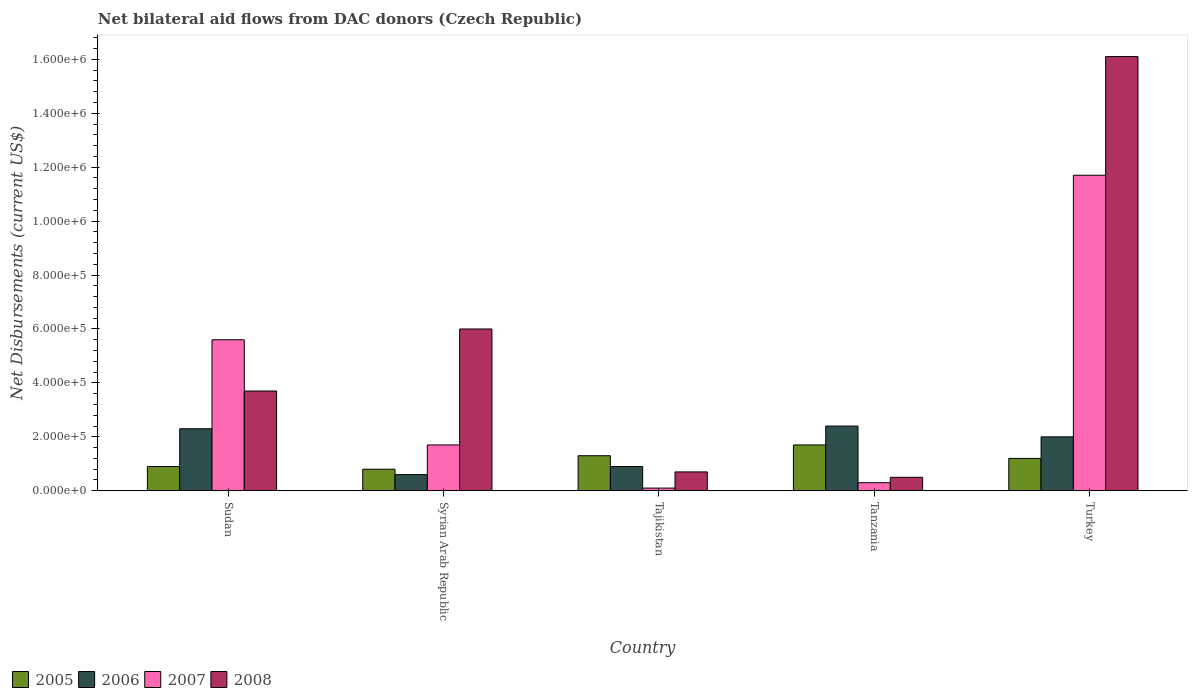Are the number of bars on each tick of the X-axis equal?
Your response must be concise. Yes. What is the label of the 2nd group of bars from the left?
Your answer should be compact. Syrian Arab Republic. In how many cases, is the number of bars for a given country not equal to the number of legend labels?
Your response must be concise. 0. Across all countries, what is the maximum net bilateral aid flows in 2005?
Make the answer very short. 1.70e+05. In which country was the net bilateral aid flows in 2005 maximum?
Provide a succinct answer. Tanzania. In which country was the net bilateral aid flows in 2007 minimum?
Offer a very short reply. Tajikistan. What is the total net bilateral aid flows in 2005 in the graph?
Your answer should be very brief. 5.90e+05. What is the difference between the net bilateral aid flows in 2007 in Tajikistan and the net bilateral aid flows in 2006 in Sudan?
Give a very brief answer. -2.20e+05. What is the average net bilateral aid flows in 2005 per country?
Provide a short and direct response. 1.18e+05. What is the difference between the highest and the lowest net bilateral aid flows in 2008?
Ensure brevity in your answer.  1.56e+06. Is the sum of the net bilateral aid flows in 2007 in Tanzania and Turkey greater than the maximum net bilateral aid flows in 2006 across all countries?
Your response must be concise. Yes. Is it the case that in every country, the sum of the net bilateral aid flows in 2006 and net bilateral aid flows in 2005 is greater than the sum of net bilateral aid flows in 2008 and net bilateral aid flows in 2007?
Provide a short and direct response. No. What does the 3rd bar from the left in Turkey represents?
Keep it short and to the point. 2007. Is it the case that in every country, the sum of the net bilateral aid flows in 2006 and net bilateral aid flows in 2005 is greater than the net bilateral aid flows in 2007?
Provide a short and direct response. No. How many bars are there?
Offer a terse response. 20. Are all the bars in the graph horizontal?
Your answer should be very brief. No. How many countries are there in the graph?
Your response must be concise. 5. Are the values on the major ticks of Y-axis written in scientific E-notation?
Your response must be concise. Yes. Does the graph contain grids?
Keep it short and to the point. No. Where does the legend appear in the graph?
Provide a succinct answer. Bottom left. How are the legend labels stacked?
Provide a short and direct response. Horizontal. What is the title of the graph?
Make the answer very short. Net bilateral aid flows from DAC donors (Czech Republic). Does "2013" appear as one of the legend labels in the graph?
Your answer should be very brief. No. What is the label or title of the Y-axis?
Your response must be concise. Net Disbursements (current US$). What is the Net Disbursements (current US$) in 2006 in Sudan?
Provide a short and direct response. 2.30e+05. What is the Net Disbursements (current US$) of 2007 in Sudan?
Offer a terse response. 5.60e+05. What is the Net Disbursements (current US$) of 2005 in Syrian Arab Republic?
Your response must be concise. 8.00e+04. What is the Net Disbursements (current US$) in 2006 in Syrian Arab Republic?
Provide a succinct answer. 6.00e+04. What is the Net Disbursements (current US$) of 2008 in Syrian Arab Republic?
Provide a succinct answer. 6.00e+05. What is the Net Disbursements (current US$) in 2005 in Tanzania?
Provide a short and direct response. 1.70e+05. What is the Net Disbursements (current US$) of 2006 in Tanzania?
Offer a very short reply. 2.40e+05. What is the Net Disbursements (current US$) in 2007 in Tanzania?
Provide a short and direct response. 3.00e+04. What is the Net Disbursements (current US$) in 2006 in Turkey?
Ensure brevity in your answer.  2.00e+05. What is the Net Disbursements (current US$) of 2007 in Turkey?
Offer a very short reply. 1.17e+06. What is the Net Disbursements (current US$) of 2008 in Turkey?
Your answer should be compact. 1.61e+06. Across all countries, what is the maximum Net Disbursements (current US$) in 2005?
Provide a succinct answer. 1.70e+05. Across all countries, what is the maximum Net Disbursements (current US$) in 2007?
Keep it short and to the point. 1.17e+06. Across all countries, what is the maximum Net Disbursements (current US$) in 2008?
Keep it short and to the point. 1.61e+06. Across all countries, what is the minimum Net Disbursements (current US$) of 2005?
Offer a terse response. 8.00e+04. Across all countries, what is the minimum Net Disbursements (current US$) in 2006?
Offer a very short reply. 6.00e+04. Across all countries, what is the minimum Net Disbursements (current US$) of 2007?
Provide a succinct answer. 10000. Across all countries, what is the minimum Net Disbursements (current US$) in 2008?
Provide a short and direct response. 5.00e+04. What is the total Net Disbursements (current US$) of 2005 in the graph?
Keep it short and to the point. 5.90e+05. What is the total Net Disbursements (current US$) of 2006 in the graph?
Provide a succinct answer. 8.20e+05. What is the total Net Disbursements (current US$) in 2007 in the graph?
Offer a very short reply. 1.94e+06. What is the total Net Disbursements (current US$) in 2008 in the graph?
Your answer should be very brief. 2.70e+06. What is the difference between the Net Disbursements (current US$) of 2006 in Sudan and that in Syrian Arab Republic?
Your answer should be very brief. 1.70e+05. What is the difference between the Net Disbursements (current US$) in 2006 in Sudan and that in Tajikistan?
Your response must be concise. 1.40e+05. What is the difference between the Net Disbursements (current US$) in 2007 in Sudan and that in Tajikistan?
Ensure brevity in your answer.  5.50e+05. What is the difference between the Net Disbursements (current US$) of 2008 in Sudan and that in Tajikistan?
Ensure brevity in your answer.  3.00e+05. What is the difference between the Net Disbursements (current US$) of 2005 in Sudan and that in Tanzania?
Your answer should be very brief. -8.00e+04. What is the difference between the Net Disbursements (current US$) of 2006 in Sudan and that in Tanzania?
Your answer should be compact. -10000. What is the difference between the Net Disbursements (current US$) in 2007 in Sudan and that in Tanzania?
Keep it short and to the point. 5.30e+05. What is the difference between the Net Disbursements (current US$) in 2008 in Sudan and that in Tanzania?
Offer a terse response. 3.20e+05. What is the difference between the Net Disbursements (current US$) in 2005 in Sudan and that in Turkey?
Offer a very short reply. -3.00e+04. What is the difference between the Net Disbursements (current US$) in 2006 in Sudan and that in Turkey?
Ensure brevity in your answer.  3.00e+04. What is the difference between the Net Disbursements (current US$) in 2007 in Sudan and that in Turkey?
Make the answer very short. -6.10e+05. What is the difference between the Net Disbursements (current US$) in 2008 in Sudan and that in Turkey?
Provide a short and direct response. -1.24e+06. What is the difference between the Net Disbursements (current US$) in 2005 in Syrian Arab Republic and that in Tajikistan?
Provide a succinct answer. -5.00e+04. What is the difference between the Net Disbursements (current US$) in 2006 in Syrian Arab Republic and that in Tajikistan?
Give a very brief answer. -3.00e+04. What is the difference between the Net Disbursements (current US$) of 2007 in Syrian Arab Republic and that in Tajikistan?
Make the answer very short. 1.60e+05. What is the difference between the Net Disbursements (current US$) of 2008 in Syrian Arab Republic and that in Tajikistan?
Keep it short and to the point. 5.30e+05. What is the difference between the Net Disbursements (current US$) of 2006 in Syrian Arab Republic and that in Tanzania?
Your answer should be very brief. -1.80e+05. What is the difference between the Net Disbursements (current US$) of 2007 in Syrian Arab Republic and that in Tanzania?
Your answer should be compact. 1.40e+05. What is the difference between the Net Disbursements (current US$) in 2005 in Syrian Arab Republic and that in Turkey?
Provide a short and direct response. -4.00e+04. What is the difference between the Net Disbursements (current US$) of 2006 in Syrian Arab Republic and that in Turkey?
Your answer should be very brief. -1.40e+05. What is the difference between the Net Disbursements (current US$) in 2007 in Syrian Arab Republic and that in Turkey?
Your answer should be compact. -1.00e+06. What is the difference between the Net Disbursements (current US$) in 2008 in Syrian Arab Republic and that in Turkey?
Provide a succinct answer. -1.01e+06. What is the difference between the Net Disbursements (current US$) of 2005 in Tajikistan and that in Tanzania?
Offer a very short reply. -4.00e+04. What is the difference between the Net Disbursements (current US$) of 2006 in Tajikistan and that in Tanzania?
Give a very brief answer. -1.50e+05. What is the difference between the Net Disbursements (current US$) in 2008 in Tajikistan and that in Tanzania?
Give a very brief answer. 2.00e+04. What is the difference between the Net Disbursements (current US$) in 2007 in Tajikistan and that in Turkey?
Your response must be concise. -1.16e+06. What is the difference between the Net Disbursements (current US$) in 2008 in Tajikistan and that in Turkey?
Provide a short and direct response. -1.54e+06. What is the difference between the Net Disbursements (current US$) in 2007 in Tanzania and that in Turkey?
Keep it short and to the point. -1.14e+06. What is the difference between the Net Disbursements (current US$) of 2008 in Tanzania and that in Turkey?
Your answer should be very brief. -1.56e+06. What is the difference between the Net Disbursements (current US$) of 2005 in Sudan and the Net Disbursements (current US$) of 2006 in Syrian Arab Republic?
Your response must be concise. 3.00e+04. What is the difference between the Net Disbursements (current US$) in 2005 in Sudan and the Net Disbursements (current US$) in 2008 in Syrian Arab Republic?
Offer a very short reply. -5.10e+05. What is the difference between the Net Disbursements (current US$) in 2006 in Sudan and the Net Disbursements (current US$) in 2008 in Syrian Arab Republic?
Your answer should be very brief. -3.70e+05. What is the difference between the Net Disbursements (current US$) of 2005 in Sudan and the Net Disbursements (current US$) of 2007 in Tajikistan?
Make the answer very short. 8.00e+04. What is the difference between the Net Disbursements (current US$) of 2006 in Sudan and the Net Disbursements (current US$) of 2007 in Tajikistan?
Provide a short and direct response. 2.20e+05. What is the difference between the Net Disbursements (current US$) in 2006 in Sudan and the Net Disbursements (current US$) in 2008 in Tajikistan?
Your answer should be compact. 1.60e+05. What is the difference between the Net Disbursements (current US$) in 2007 in Sudan and the Net Disbursements (current US$) in 2008 in Tajikistan?
Give a very brief answer. 4.90e+05. What is the difference between the Net Disbursements (current US$) in 2005 in Sudan and the Net Disbursements (current US$) in 2007 in Tanzania?
Your answer should be compact. 6.00e+04. What is the difference between the Net Disbursements (current US$) of 2005 in Sudan and the Net Disbursements (current US$) of 2008 in Tanzania?
Offer a very short reply. 4.00e+04. What is the difference between the Net Disbursements (current US$) in 2007 in Sudan and the Net Disbursements (current US$) in 2008 in Tanzania?
Your response must be concise. 5.10e+05. What is the difference between the Net Disbursements (current US$) in 2005 in Sudan and the Net Disbursements (current US$) in 2006 in Turkey?
Your answer should be very brief. -1.10e+05. What is the difference between the Net Disbursements (current US$) of 2005 in Sudan and the Net Disbursements (current US$) of 2007 in Turkey?
Your answer should be very brief. -1.08e+06. What is the difference between the Net Disbursements (current US$) of 2005 in Sudan and the Net Disbursements (current US$) of 2008 in Turkey?
Offer a terse response. -1.52e+06. What is the difference between the Net Disbursements (current US$) in 2006 in Sudan and the Net Disbursements (current US$) in 2007 in Turkey?
Your answer should be compact. -9.40e+05. What is the difference between the Net Disbursements (current US$) in 2006 in Sudan and the Net Disbursements (current US$) in 2008 in Turkey?
Your answer should be very brief. -1.38e+06. What is the difference between the Net Disbursements (current US$) of 2007 in Sudan and the Net Disbursements (current US$) of 2008 in Turkey?
Give a very brief answer. -1.05e+06. What is the difference between the Net Disbursements (current US$) of 2005 in Syrian Arab Republic and the Net Disbursements (current US$) of 2006 in Tajikistan?
Give a very brief answer. -10000. What is the difference between the Net Disbursements (current US$) in 2005 in Syrian Arab Republic and the Net Disbursements (current US$) in 2007 in Tajikistan?
Provide a succinct answer. 7.00e+04. What is the difference between the Net Disbursements (current US$) of 2006 in Syrian Arab Republic and the Net Disbursements (current US$) of 2007 in Tajikistan?
Your answer should be compact. 5.00e+04. What is the difference between the Net Disbursements (current US$) of 2005 in Syrian Arab Republic and the Net Disbursements (current US$) of 2008 in Tanzania?
Keep it short and to the point. 3.00e+04. What is the difference between the Net Disbursements (current US$) of 2007 in Syrian Arab Republic and the Net Disbursements (current US$) of 2008 in Tanzania?
Give a very brief answer. 1.20e+05. What is the difference between the Net Disbursements (current US$) in 2005 in Syrian Arab Republic and the Net Disbursements (current US$) in 2007 in Turkey?
Your answer should be very brief. -1.09e+06. What is the difference between the Net Disbursements (current US$) of 2005 in Syrian Arab Republic and the Net Disbursements (current US$) of 2008 in Turkey?
Keep it short and to the point. -1.53e+06. What is the difference between the Net Disbursements (current US$) in 2006 in Syrian Arab Republic and the Net Disbursements (current US$) in 2007 in Turkey?
Keep it short and to the point. -1.11e+06. What is the difference between the Net Disbursements (current US$) in 2006 in Syrian Arab Republic and the Net Disbursements (current US$) in 2008 in Turkey?
Make the answer very short. -1.55e+06. What is the difference between the Net Disbursements (current US$) of 2007 in Syrian Arab Republic and the Net Disbursements (current US$) of 2008 in Turkey?
Your answer should be very brief. -1.44e+06. What is the difference between the Net Disbursements (current US$) in 2005 in Tajikistan and the Net Disbursements (current US$) in 2006 in Tanzania?
Your answer should be very brief. -1.10e+05. What is the difference between the Net Disbursements (current US$) in 2005 in Tajikistan and the Net Disbursements (current US$) in 2008 in Tanzania?
Your response must be concise. 8.00e+04. What is the difference between the Net Disbursements (current US$) in 2007 in Tajikistan and the Net Disbursements (current US$) in 2008 in Tanzania?
Ensure brevity in your answer.  -4.00e+04. What is the difference between the Net Disbursements (current US$) in 2005 in Tajikistan and the Net Disbursements (current US$) in 2007 in Turkey?
Provide a succinct answer. -1.04e+06. What is the difference between the Net Disbursements (current US$) of 2005 in Tajikistan and the Net Disbursements (current US$) of 2008 in Turkey?
Offer a terse response. -1.48e+06. What is the difference between the Net Disbursements (current US$) in 2006 in Tajikistan and the Net Disbursements (current US$) in 2007 in Turkey?
Your answer should be compact. -1.08e+06. What is the difference between the Net Disbursements (current US$) of 2006 in Tajikistan and the Net Disbursements (current US$) of 2008 in Turkey?
Ensure brevity in your answer.  -1.52e+06. What is the difference between the Net Disbursements (current US$) in 2007 in Tajikistan and the Net Disbursements (current US$) in 2008 in Turkey?
Your answer should be compact. -1.60e+06. What is the difference between the Net Disbursements (current US$) in 2005 in Tanzania and the Net Disbursements (current US$) in 2006 in Turkey?
Make the answer very short. -3.00e+04. What is the difference between the Net Disbursements (current US$) of 2005 in Tanzania and the Net Disbursements (current US$) of 2007 in Turkey?
Make the answer very short. -1.00e+06. What is the difference between the Net Disbursements (current US$) in 2005 in Tanzania and the Net Disbursements (current US$) in 2008 in Turkey?
Make the answer very short. -1.44e+06. What is the difference between the Net Disbursements (current US$) of 2006 in Tanzania and the Net Disbursements (current US$) of 2007 in Turkey?
Provide a short and direct response. -9.30e+05. What is the difference between the Net Disbursements (current US$) in 2006 in Tanzania and the Net Disbursements (current US$) in 2008 in Turkey?
Ensure brevity in your answer.  -1.37e+06. What is the difference between the Net Disbursements (current US$) of 2007 in Tanzania and the Net Disbursements (current US$) of 2008 in Turkey?
Ensure brevity in your answer.  -1.58e+06. What is the average Net Disbursements (current US$) of 2005 per country?
Give a very brief answer. 1.18e+05. What is the average Net Disbursements (current US$) in 2006 per country?
Provide a short and direct response. 1.64e+05. What is the average Net Disbursements (current US$) in 2007 per country?
Provide a succinct answer. 3.88e+05. What is the average Net Disbursements (current US$) in 2008 per country?
Ensure brevity in your answer.  5.40e+05. What is the difference between the Net Disbursements (current US$) of 2005 and Net Disbursements (current US$) of 2006 in Sudan?
Your answer should be very brief. -1.40e+05. What is the difference between the Net Disbursements (current US$) of 2005 and Net Disbursements (current US$) of 2007 in Sudan?
Your answer should be compact. -4.70e+05. What is the difference between the Net Disbursements (current US$) in 2005 and Net Disbursements (current US$) in 2008 in Sudan?
Your response must be concise. -2.80e+05. What is the difference between the Net Disbursements (current US$) of 2006 and Net Disbursements (current US$) of 2007 in Sudan?
Offer a very short reply. -3.30e+05. What is the difference between the Net Disbursements (current US$) in 2005 and Net Disbursements (current US$) in 2006 in Syrian Arab Republic?
Provide a succinct answer. 2.00e+04. What is the difference between the Net Disbursements (current US$) in 2005 and Net Disbursements (current US$) in 2007 in Syrian Arab Republic?
Provide a short and direct response. -9.00e+04. What is the difference between the Net Disbursements (current US$) of 2005 and Net Disbursements (current US$) of 2008 in Syrian Arab Republic?
Offer a terse response. -5.20e+05. What is the difference between the Net Disbursements (current US$) in 2006 and Net Disbursements (current US$) in 2008 in Syrian Arab Republic?
Make the answer very short. -5.40e+05. What is the difference between the Net Disbursements (current US$) of 2007 and Net Disbursements (current US$) of 2008 in Syrian Arab Republic?
Your answer should be very brief. -4.30e+05. What is the difference between the Net Disbursements (current US$) of 2005 and Net Disbursements (current US$) of 2008 in Tajikistan?
Provide a short and direct response. 6.00e+04. What is the difference between the Net Disbursements (current US$) in 2006 and Net Disbursements (current US$) in 2008 in Tajikistan?
Make the answer very short. 2.00e+04. What is the difference between the Net Disbursements (current US$) in 2005 and Net Disbursements (current US$) in 2006 in Tanzania?
Provide a succinct answer. -7.00e+04. What is the difference between the Net Disbursements (current US$) of 2006 and Net Disbursements (current US$) of 2007 in Tanzania?
Give a very brief answer. 2.10e+05. What is the difference between the Net Disbursements (current US$) of 2005 and Net Disbursements (current US$) of 2007 in Turkey?
Give a very brief answer. -1.05e+06. What is the difference between the Net Disbursements (current US$) in 2005 and Net Disbursements (current US$) in 2008 in Turkey?
Give a very brief answer. -1.49e+06. What is the difference between the Net Disbursements (current US$) in 2006 and Net Disbursements (current US$) in 2007 in Turkey?
Ensure brevity in your answer.  -9.70e+05. What is the difference between the Net Disbursements (current US$) of 2006 and Net Disbursements (current US$) of 2008 in Turkey?
Make the answer very short. -1.41e+06. What is the difference between the Net Disbursements (current US$) of 2007 and Net Disbursements (current US$) of 2008 in Turkey?
Your answer should be compact. -4.40e+05. What is the ratio of the Net Disbursements (current US$) in 2005 in Sudan to that in Syrian Arab Republic?
Your answer should be very brief. 1.12. What is the ratio of the Net Disbursements (current US$) of 2006 in Sudan to that in Syrian Arab Republic?
Ensure brevity in your answer.  3.83. What is the ratio of the Net Disbursements (current US$) in 2007 in Sudan to that in Syrian Arab Republic?
Your response must be concise. 3.29. What is the ratio of the Net Disbursements (current US$) in 2008 in Sudan to that in Syrian Arab Republic?
Your response must be concise. 0.62. What is the ratio of the Net Disbursements (current US$) in 2005 in Sudan to that in Tajikistan?
Offer a very short reply. 0.69. What is the ratio of the Net Disbursements (current US$) in 2006 in Sudan to that in Tajikistan?
Offer a very short reply. 2.56. What is the ratio of the Net Disbursements (current US$) of 2008 in Sudan to that in Tajikistan?
Your answer should be compact. 5.29. What is the ratio of the Net Disbursements (current US$) of 2005 in Sudan to that in Tanzania?
Keep it short and to the point. 0.53. What is the ratio of the Net Disbursements (current US$) of 2007 in Sudan to that in Tanzania?
Make the answer very short. 18.67. What is the ratio of the Net Disbursements (current US$) in 2006 in Sudan to that in Turkey?
Your answer should be compact. 1.15. What is the ratio of the Net Disbursements (current US$) in 2007 in Sudan to that in Turkey?
Your answer should be very brief. 0.48. What is the ratio of the Net Disbursements (current US$) of 2008 in Sudan to that in Turkey?
Your answer should be compact. 0.23. What is the ratio of the Net Disbursements (current US$) of 2005 in Syrian Arab Republic to that in Tajikistan?
Provide a short and direct response. 0.62. What is the ratio of the Net Disbursements (current US$) of 2007 in Syrian Arab Republic to that in Tajikistan?
Keep it short and to the point. 17. What is the ratio of the Net Disbursements (current US$) in 2008 in Syrian Arab Republic to that in Tajikistan?
Provide a short and direct response. 8.57. What is the ratio of the Net Disbursements (current US$) in 2005 in Syrian Arab Republic to that in Tanzania?
Offer a very short reply. 0.47. What is the ratio of the Net Disbursements (current US$) in 2006 in Syrian Arab Republic to that in Tanzania?
Offer a very short reply. 0.25. What is the ratio of the Net Disbursements (current US$) of 2007 in Syrian Arab Republic to that in Tanzania?
Your answer should be compact. 5.67. What is the ratio of the Net Disbursements (current US$) in 2008 in Syrian Arab Republic to that in Tanzania?
Keep it short and to the point. 12. What is the ratio of the Net Disbursements (current US$) in 2005 in Syrian Arab Republic to that in Turkey?
Provide a succinct answer. 0.67. What is the ratio of the Net Disbursements (current US$) in 2006 in Syrian Arab Republic to that in Turkey?
Your answer should be compact. 0.3. What is the ratio of the Net Disbursements (current US$) in 2007 in Syrian Arab Republic to that in Turkey?
Ensure brevity in your answer.  0.15. What is the ratio of the Net Disbursements (current US$) in 2008 in Syrian Arab Republic to that in Turkey?
Provide a succinct answer. 0.37. What is the ratio of the Net Disbursements (current US$) in 2005 in Tajikistan to that in Tanzania?
Offer a terse response. 0.76. What is the ratio of the Net Disbursements (current US$) in 2006 in Tajikistan to that in Tanzania?
Your response must be concise. 0.38. What is the ratio of the Net Disbursements (current US$) in 2007 in Tajikistan to that in Tanzania?
Offer a very short reply. 0.33. What is the ratio of the Net Disbursements (current US$) in 2008 in Tajikistan to that in Tanzania?
Keep it short and to the point. 1.4. What is the ratio of the Net Disbursements (current US$) in 2005 in Tajikistan to that in Turkey?
Offer a terse response. 1.08. What is the ratio of the Net Disbursements (current US$) in 2006 in Tajikistan to that in Turkey?
Provide a short and direct response. 0.45. What is the ratio of the Net Disbursements (current US$) of 2007 in Tajikistan to that in Turkey?
Provide a short and direct response. 0.01. What is the ratio of the Net Disbursements (current US$) of 2008 in Tajikistan to that in Turkey?
Keep it short and to the point. 0.04. What is the ratio of the Net Disbursements (current US$) of 2005 in Tanzania to that in Turkey?
Provide a short and direct response. 1.42. What is the ratio of the Net Disbursements (current US$) of 2007 in Tanzania to that in Turkey?
Provide a succinct answer. 0.03. What is the ratio of the Net Disbursements (current US$) of 2008 in Tanzania to that in Turkey?
Make the answer very short. 0.03. What is the difference between the highest and the second highest Net Disbursements (current US$) in 2005?
Provide a succinct answer. 4.00e+04. What is the difference between the highest and the second highest Net Disbursements (current US$) of 2006?
Keep it short and to the point. 10000. What is the difference between the highest and the second highest Net Disbursements (current US$) in 2008?
Your response must be concise. 1.01e+06. What is the difference between the highest and the lowest Net Disbursements (current US$) of 2007?
Keep it short and to the point. 1.16e+06. What is the difference between the highest and the lowest Net Disbursements (current US$) of 2008?
Your answer should be very brief. 1.56e+06. 